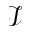<formula> <loc_0><loc_0><loc_500><loc_500>\mathcal { I }</formula> 